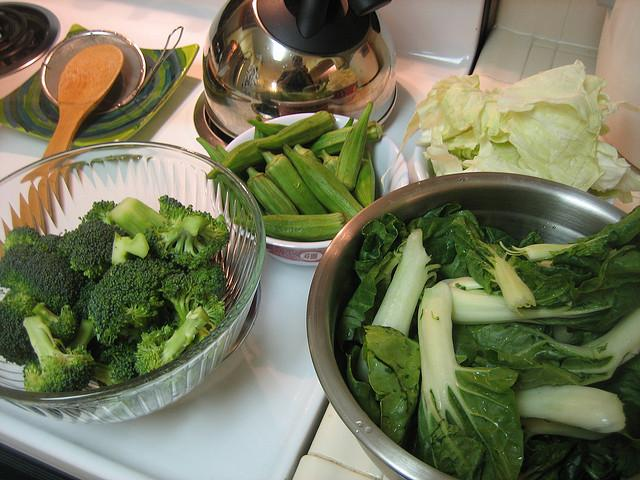What do all the foods being prepared have in common? vegetables 